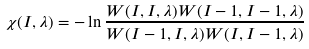<formula> <loc_0><loc_0><loc_500><loc_500>\chi ( I , \lambda ) = - \ln \frac { W ( I , I , \lambda ) W ( I - 1 , I - 1 , \lambda ) } { W ( I - 1 , I , \lambda ) W ( I , I - 1 , \lambda ) }</formula> 